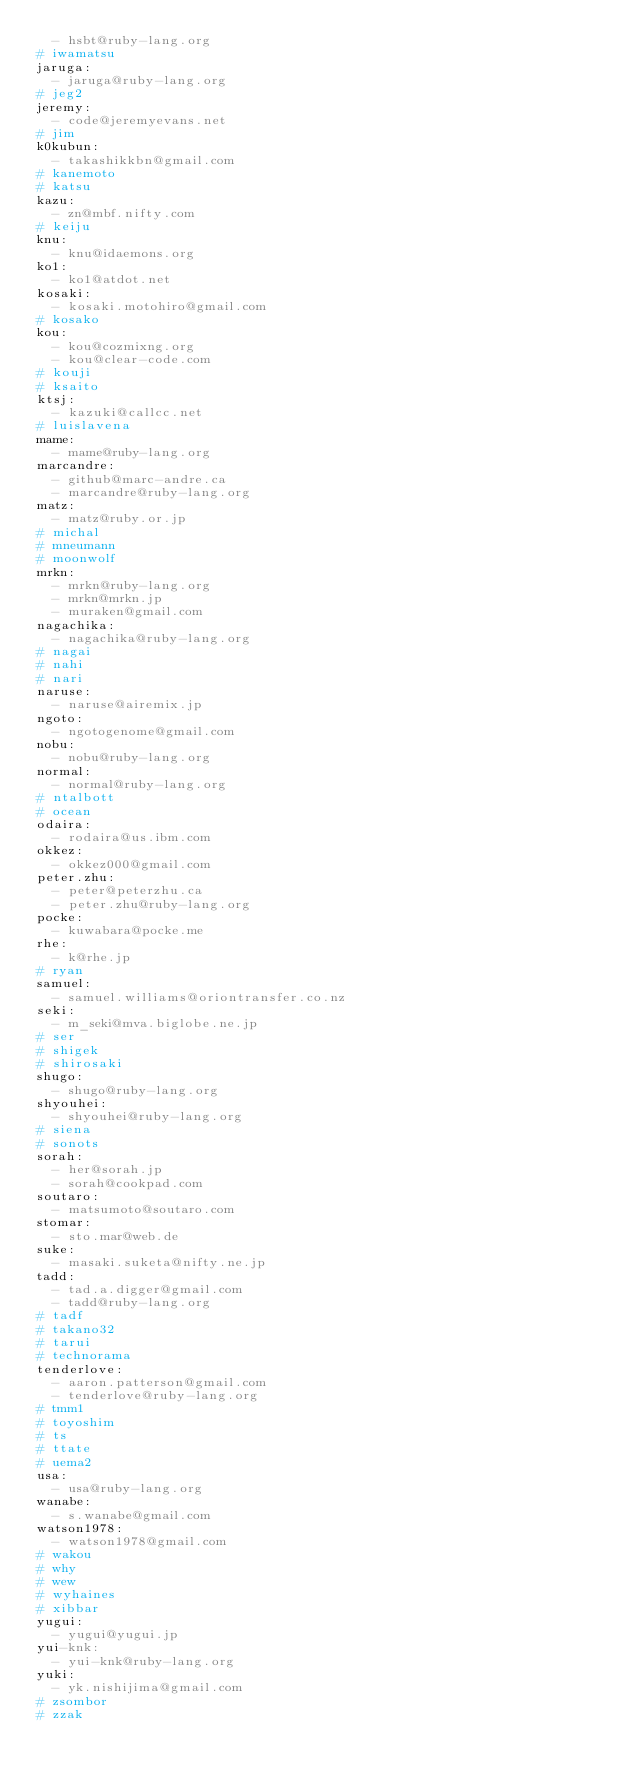<code> <loc_0><loc_0><loc_500><loc_500><_YAML_>  - hsbt@ruby-lang.org
# iwamatsu
jaruga:
  - jaruga@ruby-lang.org
# jeg2
jeremy:
  - code@jeremyevans.net
# jim
k0kubun:
  - takashikkbn@gmail.com
# kanemoto
# katsu
kazu:
  - zn@mbf.nifty.com
# keiju
knu:
  - knu@idaemons.org
ko1:
  - ko1@atdot.net
kosaki:
  - kosaki.motohiro@gmail.com
# kosako
kou:
  - kou@cozmixng.org
  - kou@clear-code.com
# kouji
# ksaito
ktsj:
  - kazuki@callcc.net
# luislavena
mame:
  - mame@ruby-lang.org
marcandre:
  - github@marc-andre.ca
  - marcandre@ruby-lang.org
matz:
  - matz@ruby.or.jp
# michal
# mneumann
# moonwolf
mrkn:
  - mrkn@ruby-lang.org
  - mrkn@mrkn.jp
  - muraken@gmail.com
nagachika:
  - nagachika@ruby-lang.org
# nagai
# nahi
# nari
naruse:
  - naruse@airemix.jp
ngoto:
  - ngotogenome@gmail.com
nobu:
  - nobu@ruby-lang.org
normal:
  - normal@ruby-lang.org
# ntalbott
# ocean
odaira:
  - rodaira@us.ibm.com
okkez:
  - okkez000@gmail.com
peter.zhu:
  - peter@peterzhu.ca
  - peter.zhu@ruby-lang.org
pocke:
  - kuwabara@pocke.me
rhe:
  - k@rhe.jp
# ryan
samuel:
  - samuel.williams@oriontransfer.co.nz
seki:
  - m_seki@mva.biglobe.ne.jp
# ser
# shigek
# shirosaki
shugo:
  - shugo@ruby-lang.org
shyouhei:
  - shyouhei@ruby-lang.org
# siena
# sonots
sorah:
  - her@sorah.jp
  - sorah@cookpad.com
soutaro:
  - matsumoto@soutaro.com
stomar:
  - sto.mar@web.de
suke:
  - masaki.suketa@nifty.ne.jp
tadd:
  - tad.a.digger@gmail.com
  - tadd@ruby-lang.org
# tadf
# takano32
# tarui
# technorama
tenderlove:
  - aaron.patterson@gmail.com
  - tenderlove@ruby-lang.org
# tmm1
# toyoshim
# ts
# ttate
# uema2
usa:
  - usa@ruby-lang.org
wanabe:
  - s.wanabe@gmail.com
watson1978:
  - watson1978@gmail.com
# wakou
# why
# wew
# wyhaines
# xibbar
yugui:
  - yugui@yugui.jp
yui-knk:
  - yui-knk@ruby-lang.org
yuki:
  - yk.nishijima@gmail.com
# zsombor
# zzak
</code> 